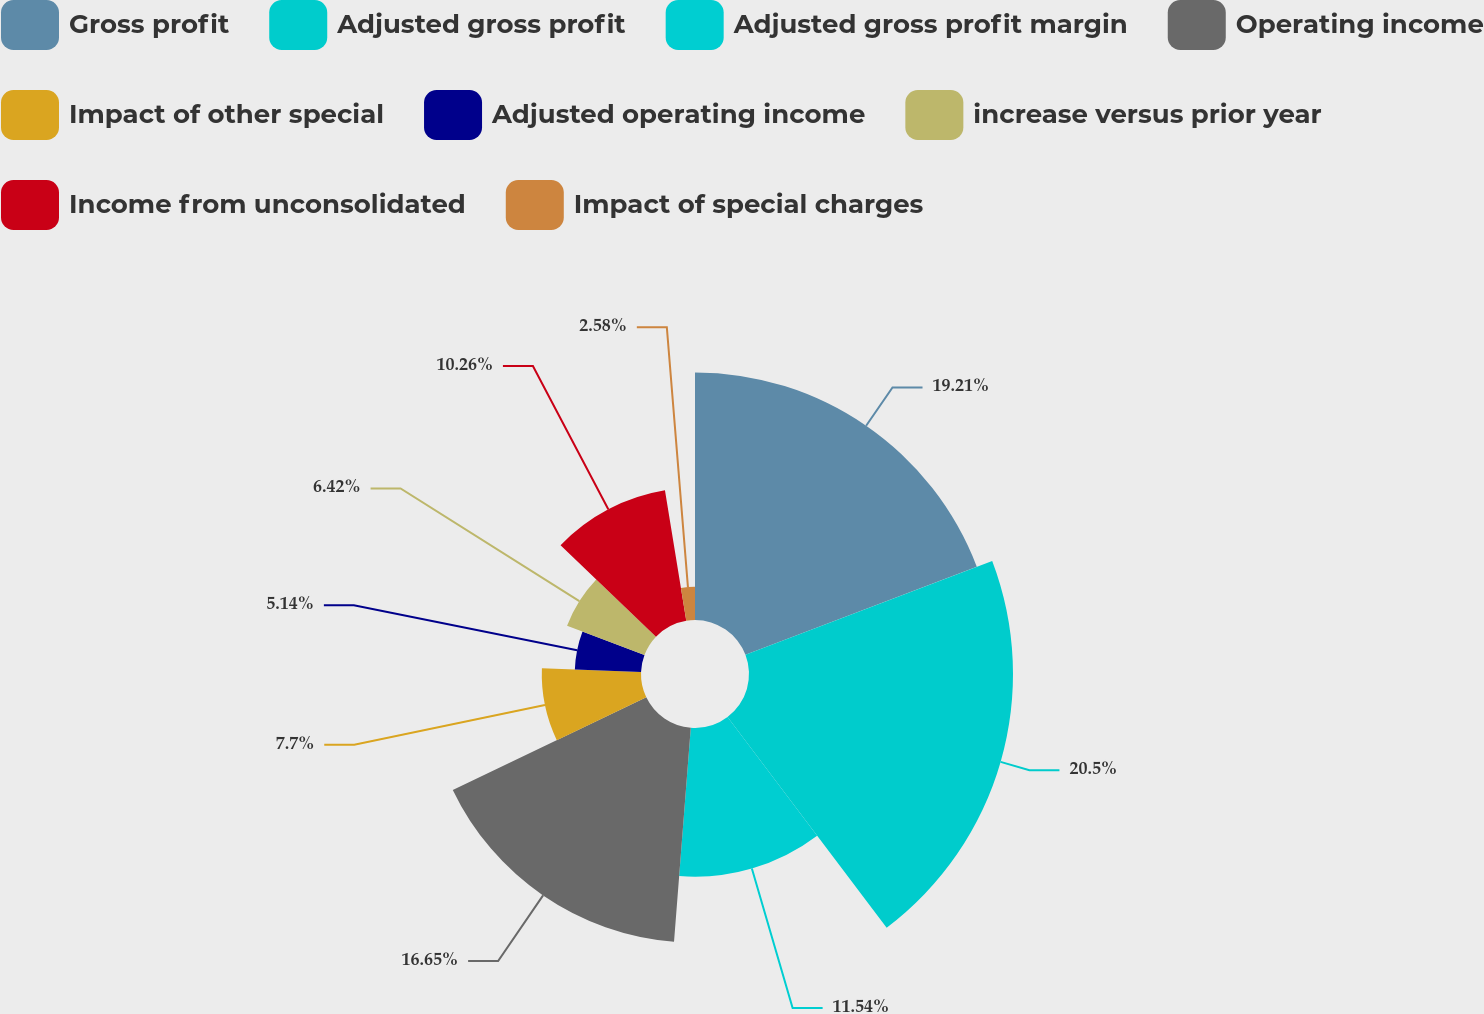Convert chart to OTSL. <chart><loc_0><loc_0><loc_500><loc_500><pie_chart><fcel>Gross profit<fcel>Adjusted gross profit<fcel>Adjusted gross profit margin<fcel>Operating income<fcel>Impact of other special<fcel>Adjusted operating income<fcel>increase versus prior year<fcel>Income from unconsolidated<fcel>Impact of special charges<nl><fcel>19.21%<fcel>20.49%<fcel>11.54%<fcel>16.65%<fcel>7.7%<fcel>5.14%<fcel>6.42%<fcel>10.26%<fcel>2.58%<nl></chart> 